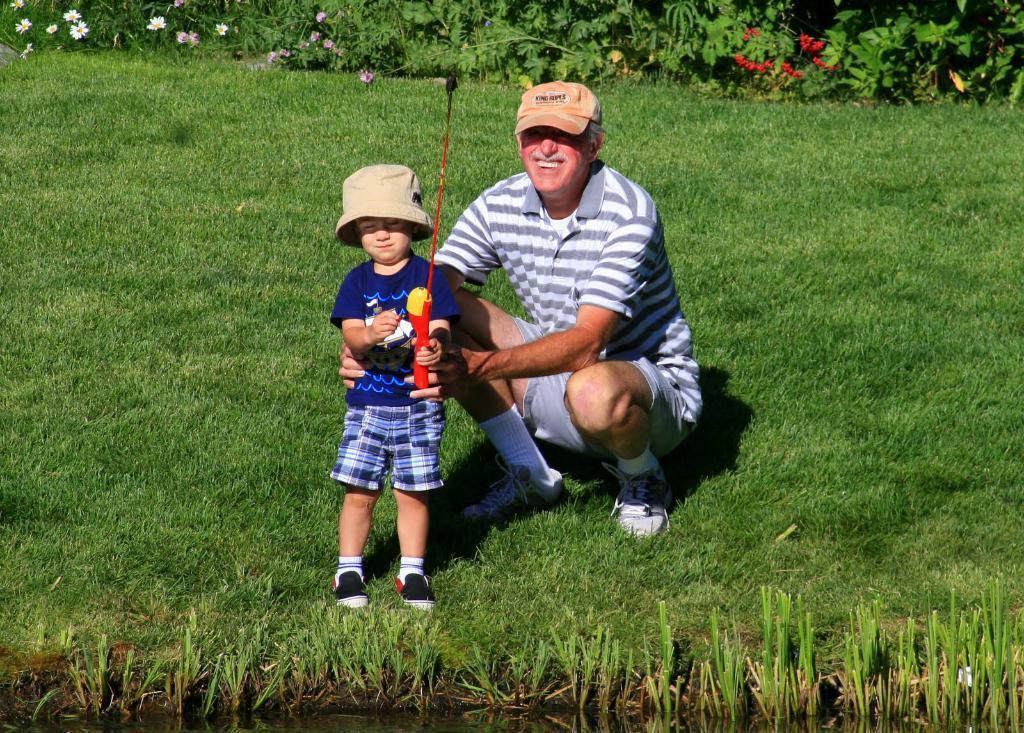In one or two sentences, can you explain what this image depicts? In the middle of this image, there is a person, smiling, squatting and holding a child who is holding an object and standing on the grass on the ground. In front of them, there is water. In the background, there are plants. Some of them are having flowers. 